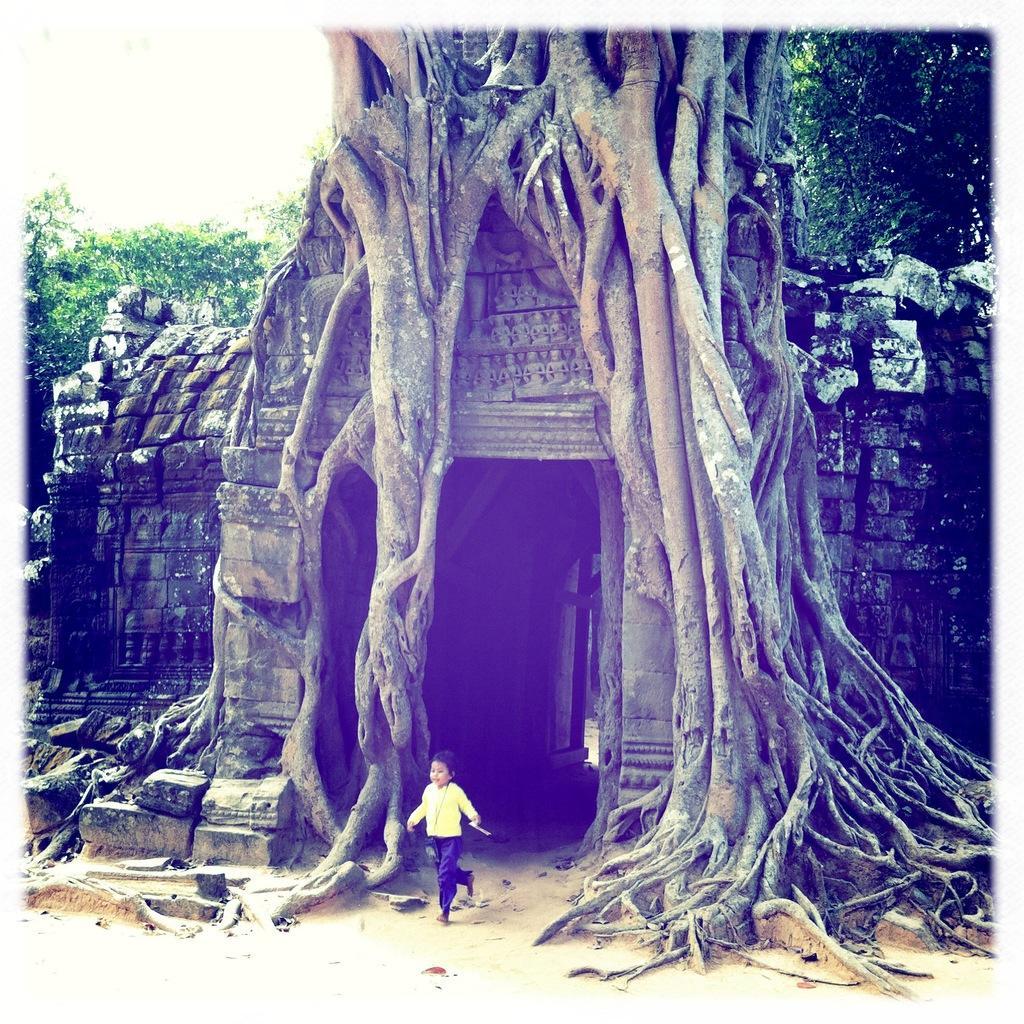Can you describe this image briefly? In this picture we can see a child running on the ground, trees, buildings and in the background we can see the sky. 